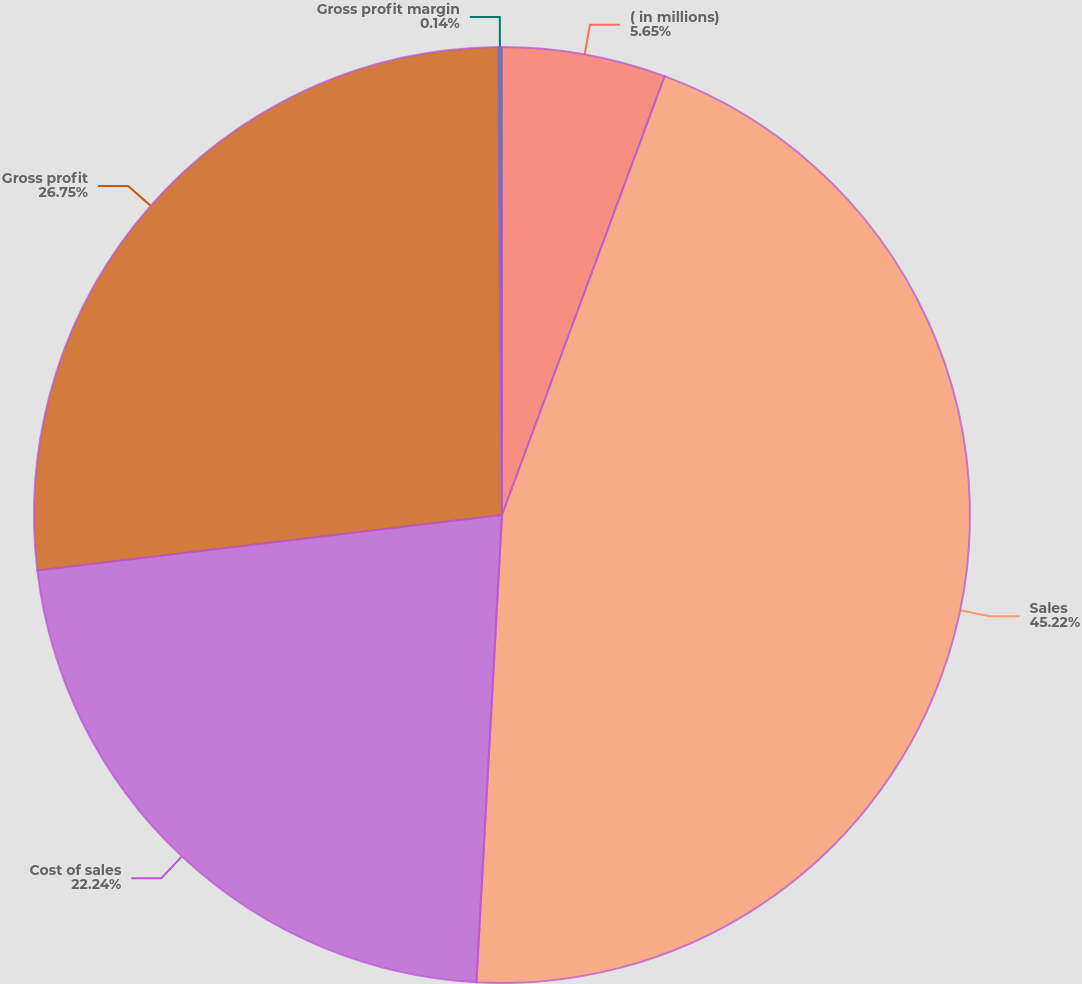Convert chart. <chart><loc_0><loc_0><loc_500><loc_500><pie_chart><fcel>( in millions)<fcel>Sales<fcel>Cost of sales<fcel>Gross profit<fcel>Gross profit margin<nl><fcel>5.65%<fcel>45.22%<fcel>22.24%<fcel>26.75%<fcel>0.14%<nl></chart> 